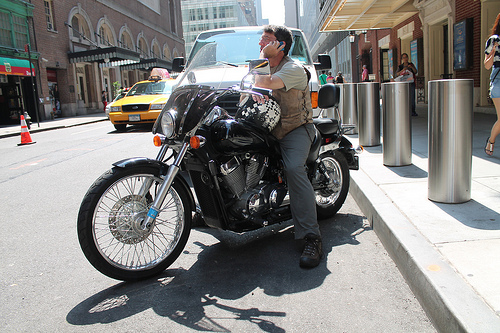Who is standing? A man is standing to the right side of the image, leaning on the motorcycle. 